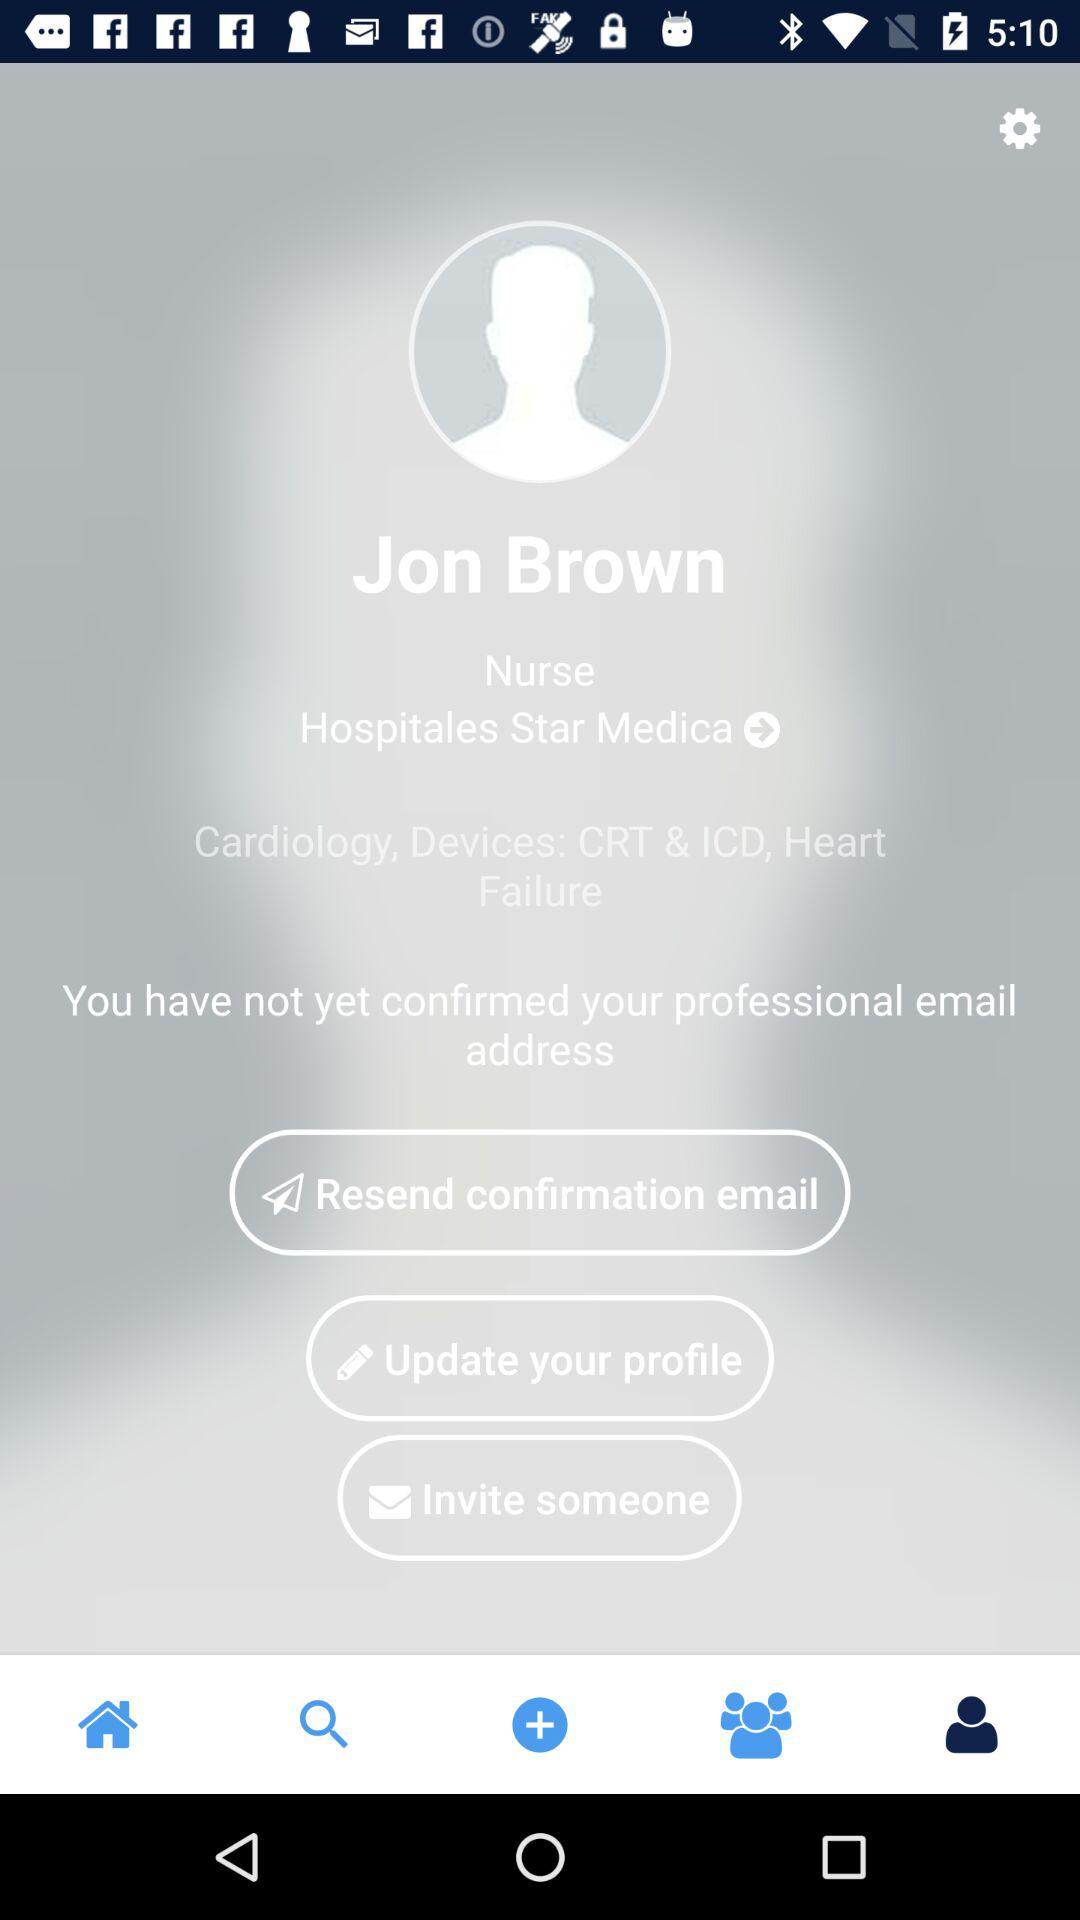What is the user name? The user name is Jon Brown. 